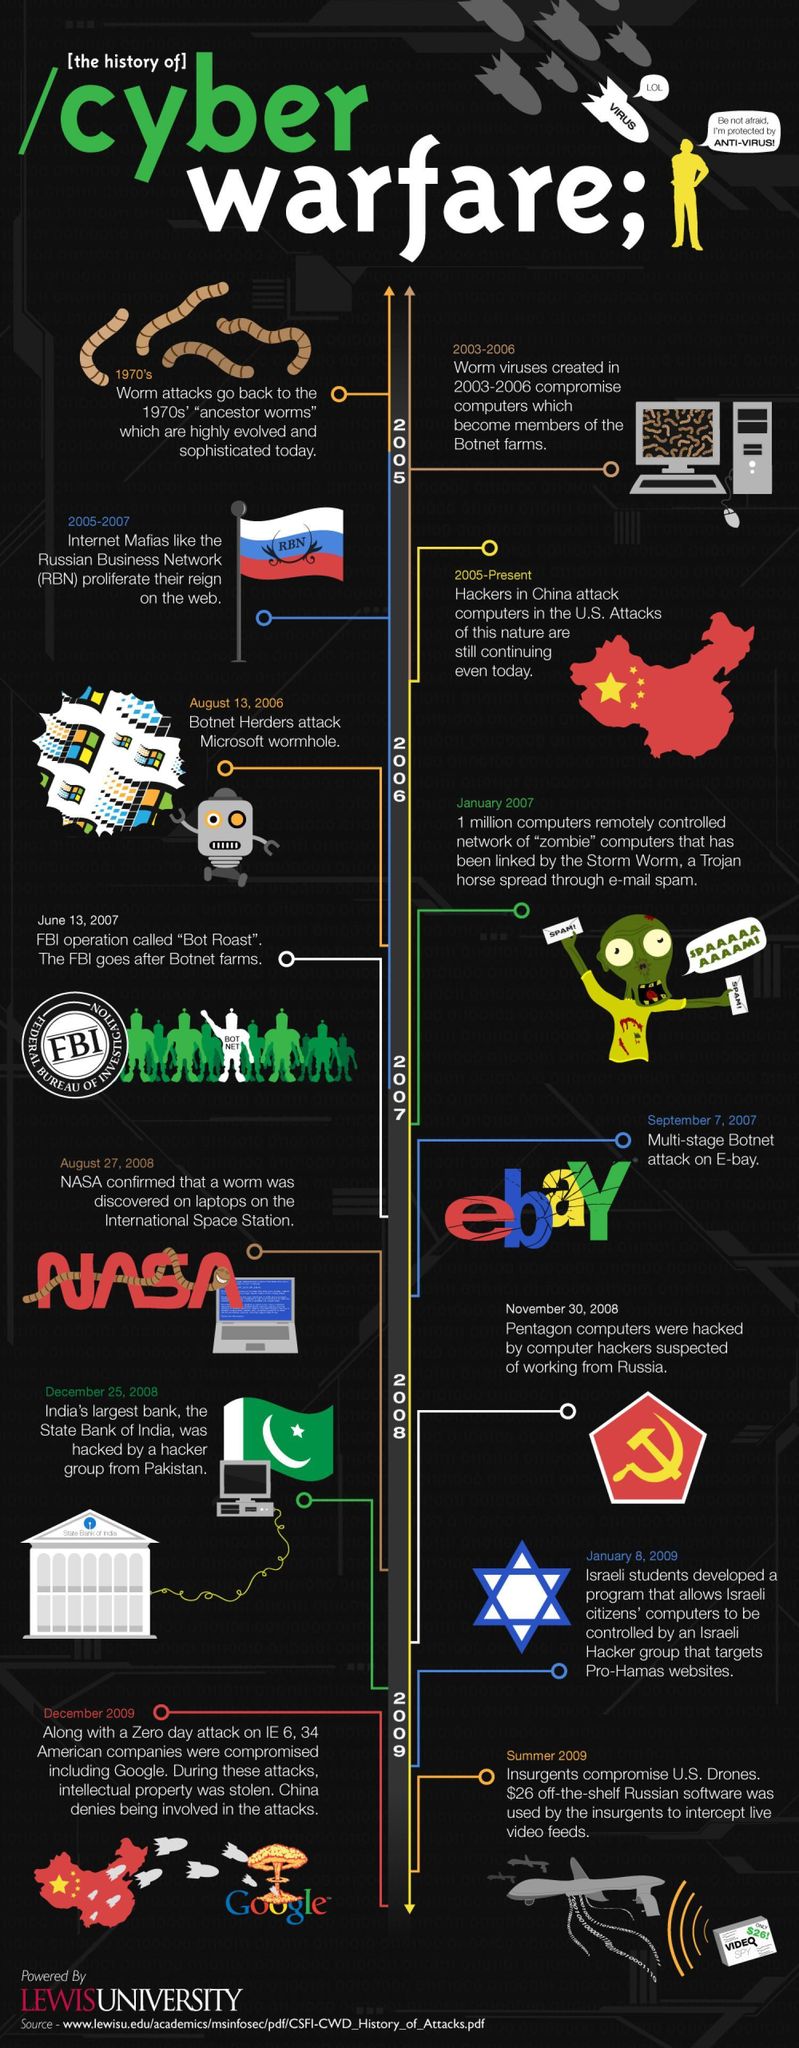What came first, Operation Bot Roast or botnet attack on eBay?
Answer the question with a short phrase. Operation Bot Roast When did RBN proliferate on the web? 2005 - 2007 Which Indian bank was hacked by Pakistani hackers and When? State Bank of India, December 25, 2008 When was eBay attacked? September 7, 2007 When did the Israeli students develop a program to hack computers of Israeli citizens? January 8, 2009 What happened first, zero day attack on IE6 or botnet attack on Microsoft? Botnet attack on Microsoft Which was the Trojan horse that allowed 1 million computers to be remotely controlled in 2007? Storm worm When were the Pentagon computers hacked? November 30, 2008 When did botnet hackers attack Microsoft wormhole? August 13, 2006 Who used Russian software to intercept US drones? Insurgents When did NASA discover a worm on laptops in the international space station? August 27, 2008 When was operation "Bot Roast" launched and by whom? June 13, 2007, FBI When was the zero day attack on IE6? December 2009 Who is suspected to have attacked 34 American companies including Google, in December 2009? China Since when have the Chinese been attacking US computers? 2005 When did insurgents attack US drones? Summer 2009 